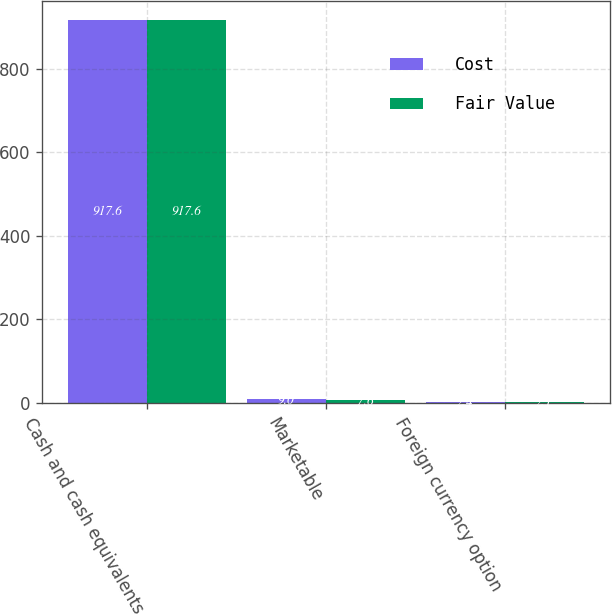<chart> <loc_0><loc_0><loc_500><loc_500><stacked_bar_chart><ecel><fcel>Cash and cash equivalents<fcel>Marketable<fcel>Foreign currency option<nl><fcel>Cost<fcel>917.6<fcel>9<fcel>2.4<nl><fcel>Fair Value<fcel>917.6<fcel>7.6<fcel>2.1<nl></chart> 